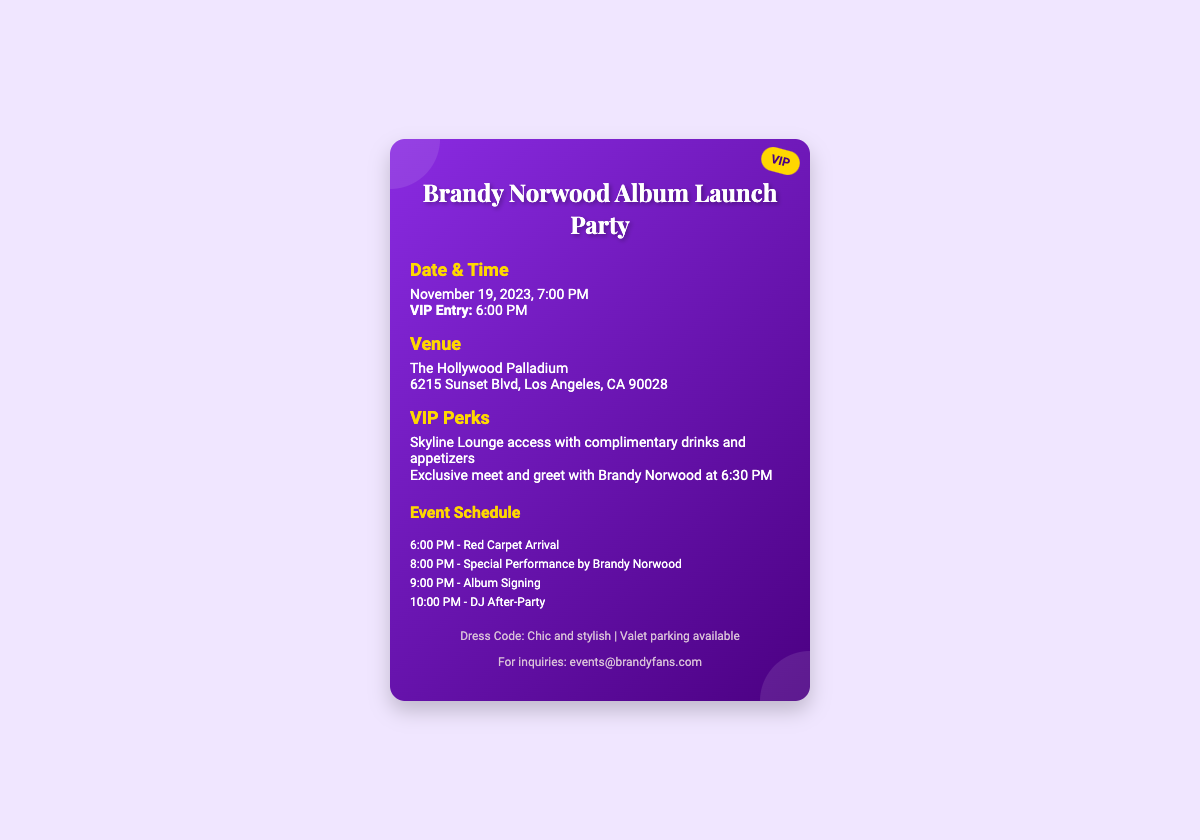What is the date of the event? The date of the event is listed in the document, which is November 19, 2023.
Answer: November 19, 2023 What time does VIP entry start? The document specifies that VIP entry starts at 6:00 PM.
Answer: 6:00 PM Where is the venue located? The venue is mentioned in the document, which is The Hollywood Palladium and its address is provided.
Answer: The Hollywood Palladium, 6215 Sunset Blvd, Los Angeles, CA 90028 What is one of the VIP perks? The document outlines several VIP perks, one of which is access to the Skyline Lounge with complimentary drinks and appetizers.
Answer: Skyline Lounge access with complimentary drinks and appetizers What time does the special performance by Brandy Norwood start? The schedule in the document indicates that the special performance by Brandy Norwood starts at 8:00 PM.
Answer: 8:00 PM What activity occurs at 9:00 PM? According to the event schedule in the document, at 9:00 PM there is an album signing event.
Answer: Album Signing What is the dress code for the event? The dress code is clearly stated in the footer of the document as “Chic and stylish.”
Answer: Chic and stylish What email address can be used for inquiries? The document provides an email address for inquiries, which is events@brandyfans.com.
Answer: events@brandyfans.com 